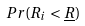Convert formula to latex. <formula><loc_0><loc_0><loc_500><loc_500>P r ( R _ { i } < \underline { R } )</formula> 